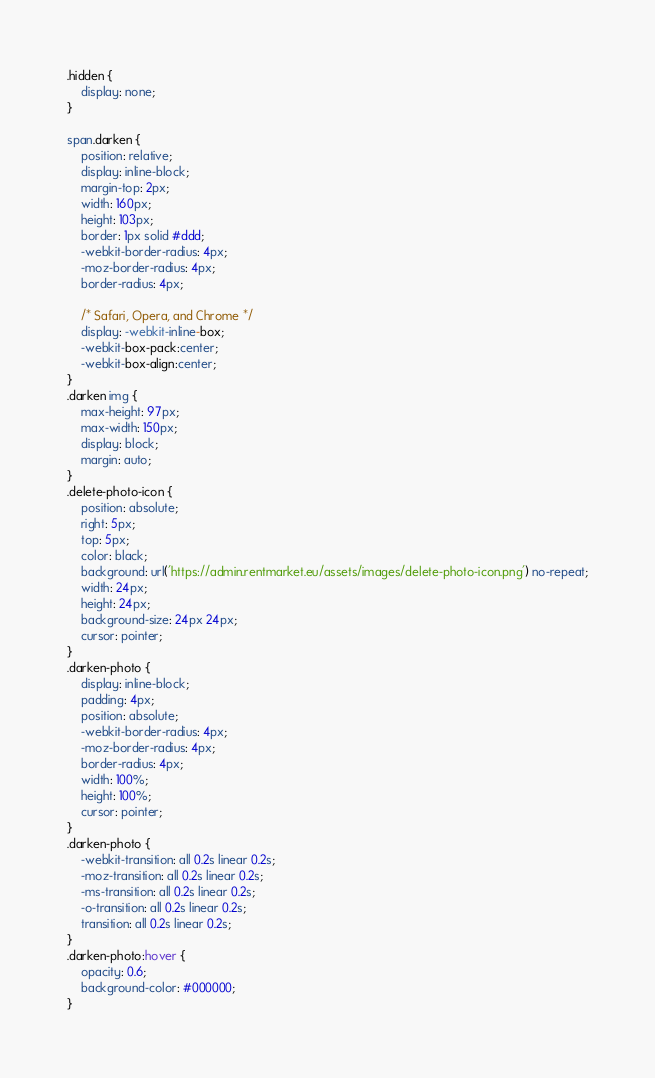<code> <loc_0><loc_0><loc_500><loc_500><_CSS_>.hidden {
    display: none;
}

span.darken {
    position: relative;
    display: inline-block;
    margin-top: 2px;
    width: 160px;
    height: 103px;
    border: 1px solid #ddd;
    -webkit-border-radius: 4px;
    -moz-border-radius: 4px;
    border-radius: 4px;

    /* Safari, Opera, and Chrome */
    display: -webkit-inline-box;
    -webkit-box-pack:center;
    -webkit-box-align:center;
}
.darken img {
    max-height: 97px;
    max-width: 150px;
    display: block;
    margin: auto;
}
.delete-photo-icon {
    position: absolute;
    right: 5px;
    top: 5px;
    color: black;
    background: url('https://admin.rentmarket.eu/assets/images/delete-photo-icon.png') no-repeat;
    width: 24px;
    height: 24px;
    background-size: 24px 24px;
    cursor: pointer;
}
.darken-photo {
    display: inline-block;
    padding: 4px;
    position: absolute;
    -webkit-border-radius: 4px;
    -moz-border-radius: 4px;
    border-radius: 4px;
    width: 100%;
    height: 100%;
    cursor: pointer;
}
.darken-photo {
    -webkit-transition: all 0.2s linear 0.2s;
    -moz-transition: all 0.2s linear 0.2s;
    -ms-transition: all 0.2s linear 0.2s;
    -o-transition: all 0.2s linear 0.2s;
    transition: all 0.2s linear 0.2s;
}
.darken-photo:hover {
    opacity: 0.6;
    background-color: #000000;
}</code> 